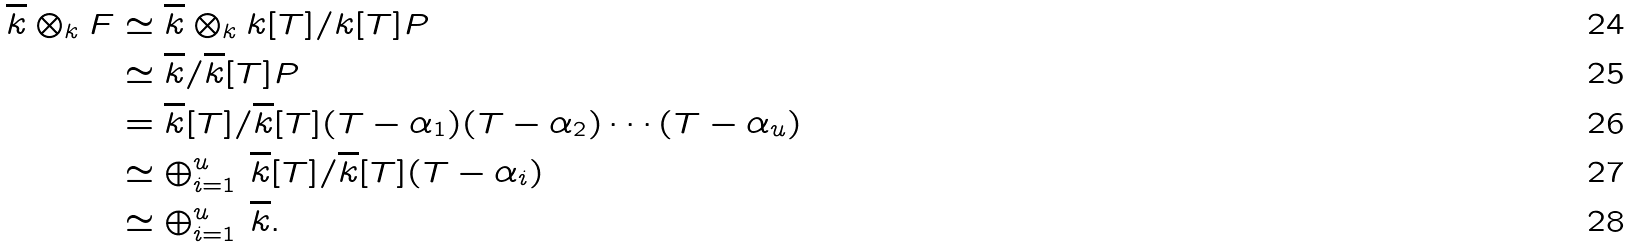Convert formula to latex. <formula><loc_0><loc_0><loc_500><loc_500>\overline { k } \otimes _ { k } F & \simeq \overline { k } \otimes _ { k } k [ T ] / k [ T ] P \\ & \simeq \overline { k } / \overline { k } [ T ] P \\ & = \overline { k } [ T ] / \overline { k } [ T ] ( T - \alpha _ { 1 } ) ( T - \alpha _ { 2 } ) \cdots ( T - \alpha _ { u } ) \\ & \simeq \oplus _ { i = 1 } ^ { u } \ \overline { k } [ T ] / \overline { k } [ T ] ( T - \alpha _ { i } ) \\ & \simeq \oplus _ { i = 1 } ^ { u } \ \overline { k } .</formula> 